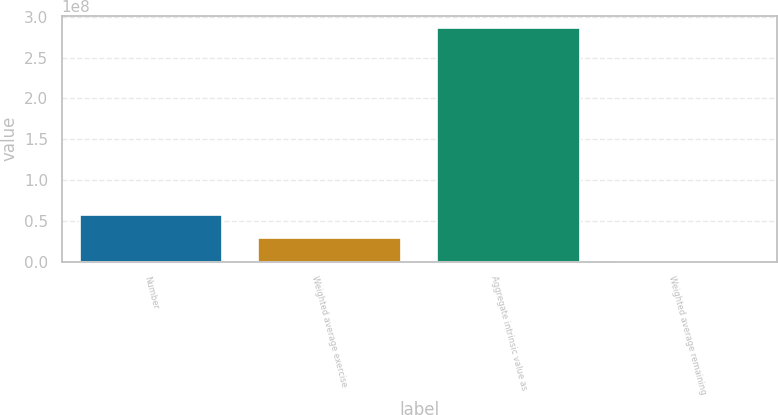<chart> <loc_0><loc_0><loc_500><loc_500><bar_chart><fcel>Number<fcel>Weighted average exercise<fcel>Aggregate intrinsic value as<fcel>Weighted average remaining<nl><fcel>5.73481e+07<fcel>2.8674e+07<fcel>2.8674e+08<fcel>2.9<nl></chart> 